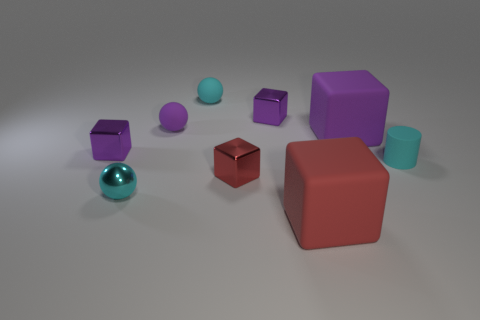Taking into account the colors present, what vibe or atmosphere do they evoke in the scene? The cool tones of blues and purples, combined with the warmth of the lone red cube, evoke a calm yet intriguing atmosphere, where each hue complements another, leading to a harmonious visual experience. 